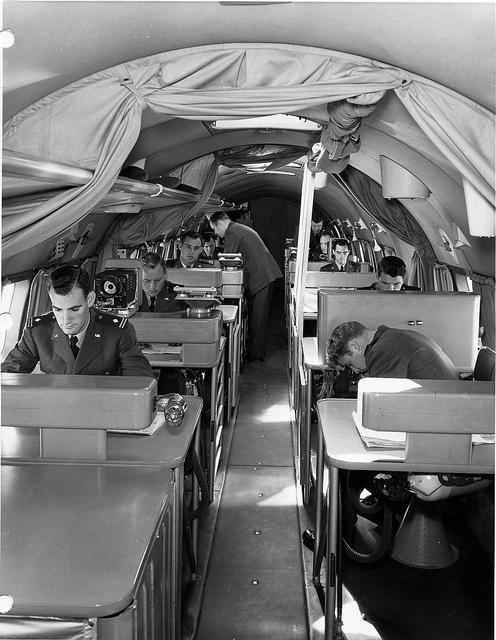How many people are there?
Give a very brief answer. 3. How many elephants are there?
Give a very brief answer. 0. 